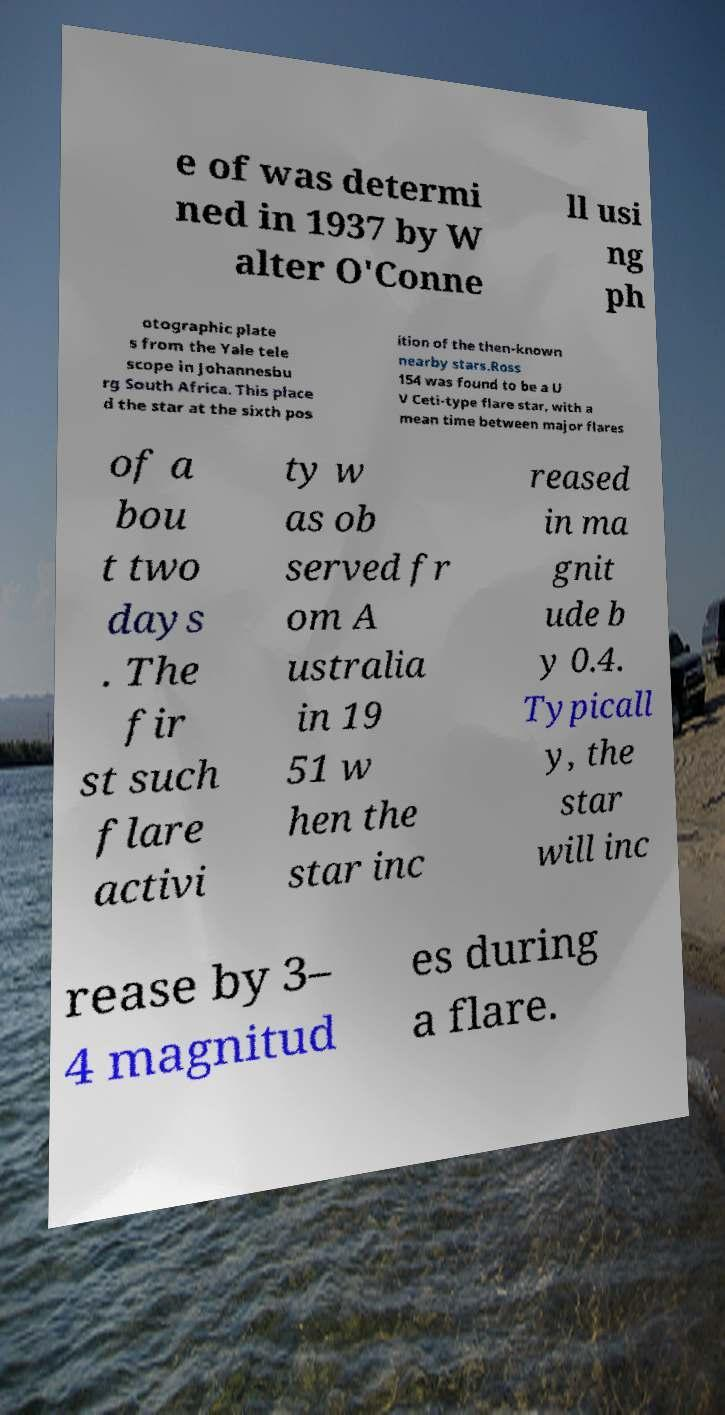There's text embedded in this image that I need extracted. Can you transcribe it verbatim? e of was determi ned in 1937 by W alter O'Conne ll usi ng ph otographic plate s from the Yale tele scope in Johannesbu rg South Africa. This place d the star at the sixth pos ition of the then-known nearby stars.Ross 154 was found to be a U V Ceti-type flare star, with a mean time between major flares of a bou t two days . The fir st such flare activi ty w as ob served fr om A ustralia in 19 51 w hen the star inc reased in ma gnit ude b y 0.4. Typicall y, the star will inc rease by 3– 4 magnitud es during a flare. 